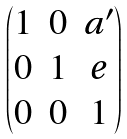Convert formula to latex. <formula><loc_0><loc_0><loc_500><loc_500>\begin{pmatrix} 1 & 0 & a ^ { \prime } \\ 0 & 1 & e \\ 0 & 0 & 1 \end{pmatrix}</formula> 